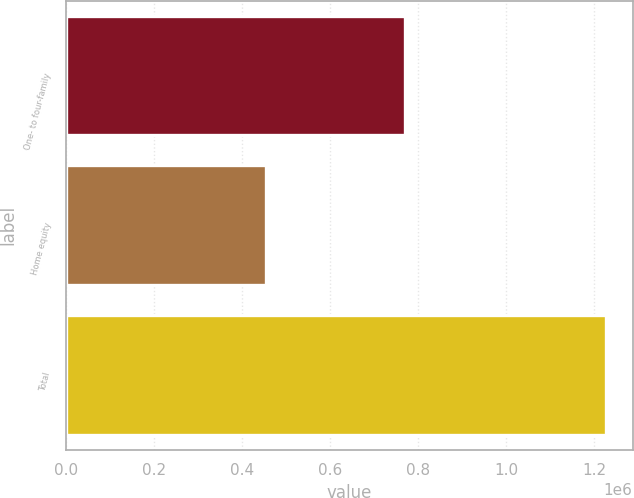Convert chart to OTSL. <chart><loc_0><loc_0><loc_500><loc_500><bar_chart><fcel>One- to four-family<fcel>Home equity<fcel>Total<nl><fcel>770943<fcel>455422<fcel>1.22636e+06<nl></chart> 